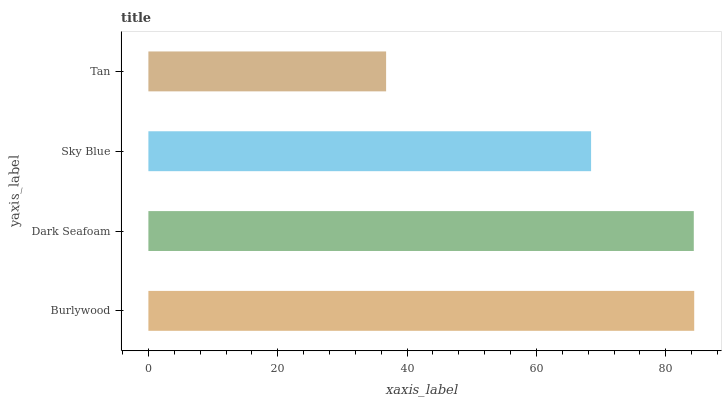Is Tan the minimum?
Answer yes or no. Yes. Is Burlywood the maximum?
Answer yes or no. Yes. Is Dark Seafoam the minimum?
Answer yes or no. No. Is Dark Seafoam the maximum?
Answer yes or no. No. Is Burlywood greater than Dark Seafoam?
Answer yes or no. Yes. Is Dark Seafoam less than Burlywood?
Answer yes or no. Yes. Is Dark Seafoam greater than Burlywood?
Answer yes or no. No. Is Burlywood less than Dark Seafoam?
Answer yes or no. No. Is Dark Seafoam the high median?
Answer yes or no. Yes. Is Sky Blue the low median?
Answer yes or no. Yes. Is Sky Blue the high median?
Answer yes or no. No. Is Dark Seafoam the low median?
Answer yes or no. No. 